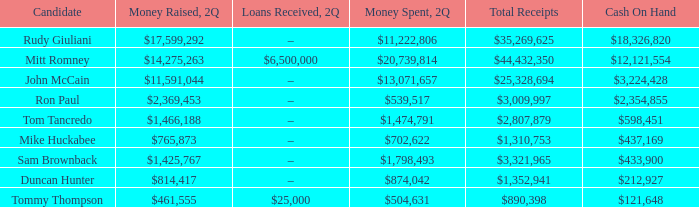Tell me the money raised when 2Q has total receipts of $890,398 $461,555. Could you parse the entire table as a dict? {'header': ['Candidate', 'Money Raised, 2Q', 'Loans Received, 2Q', 'Money Spent, 2Q', 'Total Receipts', 'Cash On Hand'], 'rows': [['Rudy Giuliani', '$17,599,292', '–', '$11,222,806', '$35,269,625', '$18,326,820'], ['Mitt Romney', '$14,275,263', '$6,500,000', '$20,739,814', '$44,432,350', '$12,121,554'], ['John McCain', '$11,591,044', '–', '$13,071,657', '$25,328,694', '$3,224,428'], ['Ron Paul', '$2,369,453', '–', '$539,517', '$3,009,997', '$2,354,855'], ['Tom Tancredo', '$1,466,188', '–', '$1,474,791', '$2,807,879', '$598,451'], ['Mike Huckabee', '$765,873', '–', '$702,622', '$1,310,753', '$437,169'], ['Sam Brownback', '$1,425,767', '–', '$1,798,493', '$3,321,965', '$433,900'], ['Duncan Hunter', '$814,417', '–', '$874,042', '$1,352,941', '$212,927'], ['Tommy Thompson', '$461,555', '$25,000', '$504,631', '$890,398', '$121,648']]} 